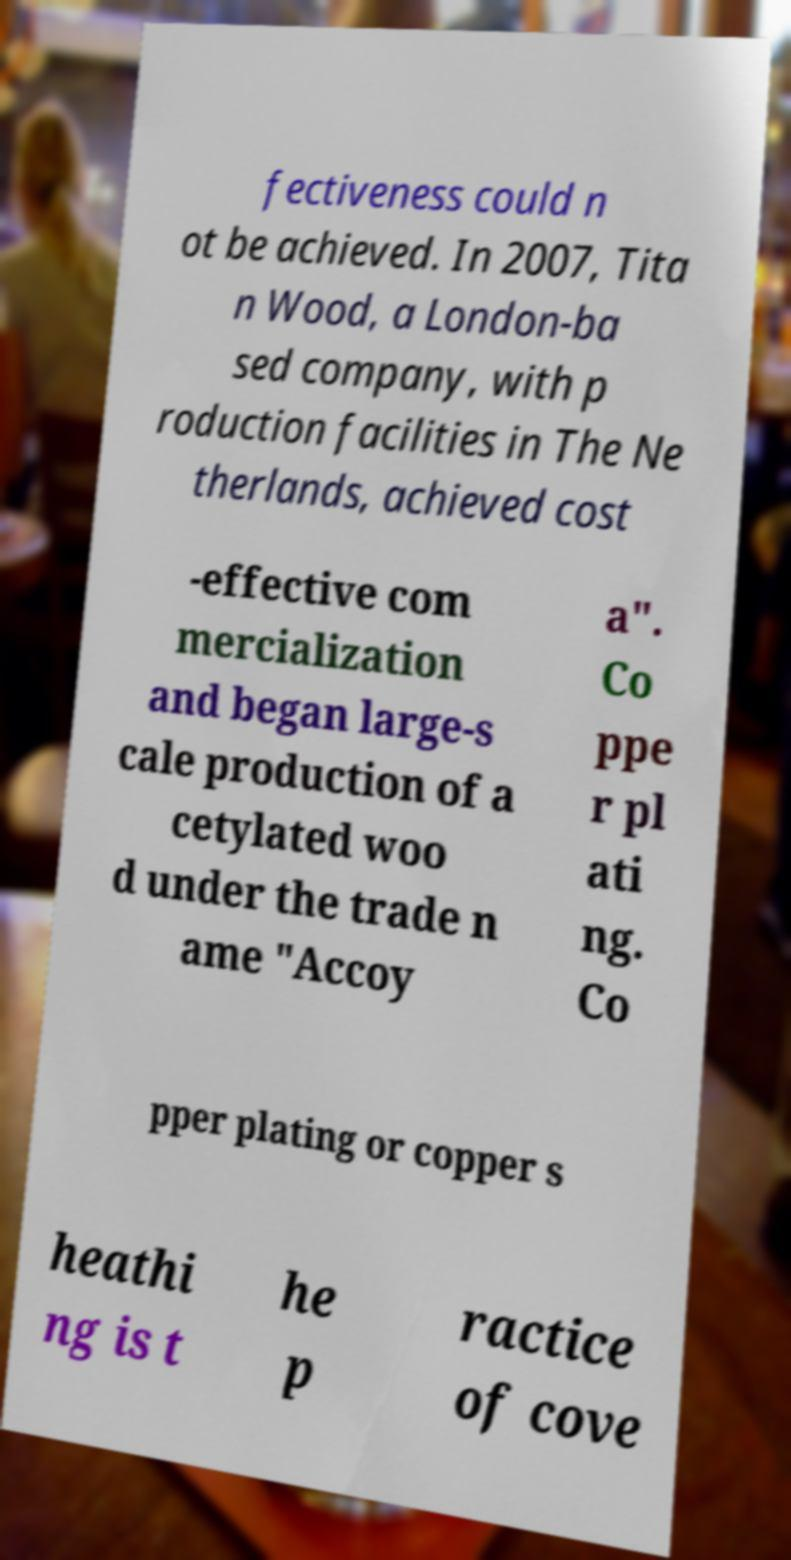Can you read and provide the text displayed in the image?This photo seems to have some interesting text. Can you extract and type it out for me? fectiveness could n ot be achieved. In 2007, Tita n Wood, a London-ba sed company, with p roduction facilities in The Ne therlands, achieved cost -effective com mercialization and began large-s cale production of a cetylated woo d under the trade n ame "Accoy a". Co ppe r pl ati ng. Co pper plating or copper s heathi ng is t he p ractice of cove 